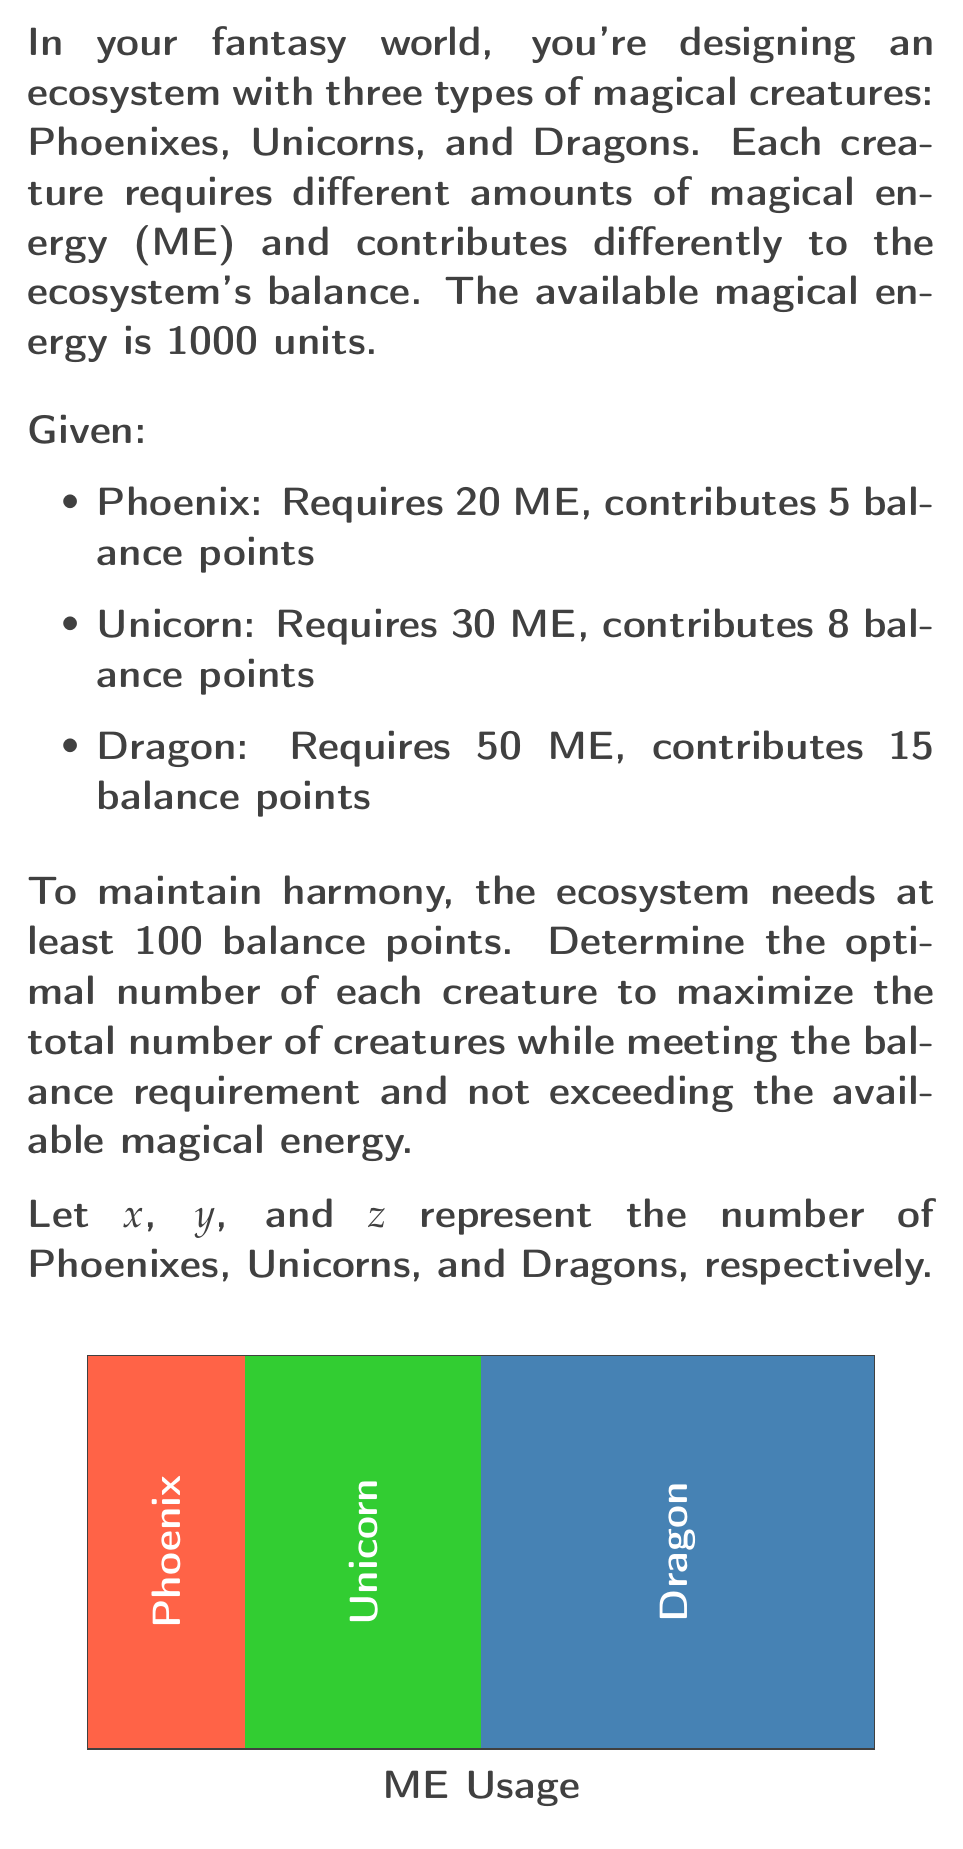Teach me how to tackle this problem. To solve this optimization problem, we'll use linear programming:

1. Objective function: Maximize the total number of creatures
   $$\text{Maximize } f(x,y,z) = x + y + z$$

2. Constraints:
   a. Magical energy constraint:
      $$20x + 30y + 50z \leq 1000$$
   b. Balance points constraint:
      $$5x + 8y + 15z \geq 100$$
   c. Non-negativity constraints:
      $$x \geq 0, y \geq 0, z \geq 0$$

3. We can solve this using the simplex method or graphical method. For simplicity, let's use a graphical approach:

   a. Plot the constraints on a 3D graph (mentally or using software).
   b. The feasible region is the intersection of these constraints.
   c. The optimal solution will be at one of the vertices of this region.

4. By testing the vertices, we find the optimal solution:
   $$x = 20, y = 20, z = 4$$

5. Verify the solution:
   - Total ME used: $20(20) + 30(20) + 50(4) = 800 \leq 1000$
   - Total balance points: $5(20) + 8(20) + 15(4) = 320 \geq 100$
   - Total creatures: $20 + 20 + 4 = 44$

This solution maximizes the total number of creatures while meeting all constraints.
Answer: 20 Phoenixes, 20 Unicorns, 4 Dragons 